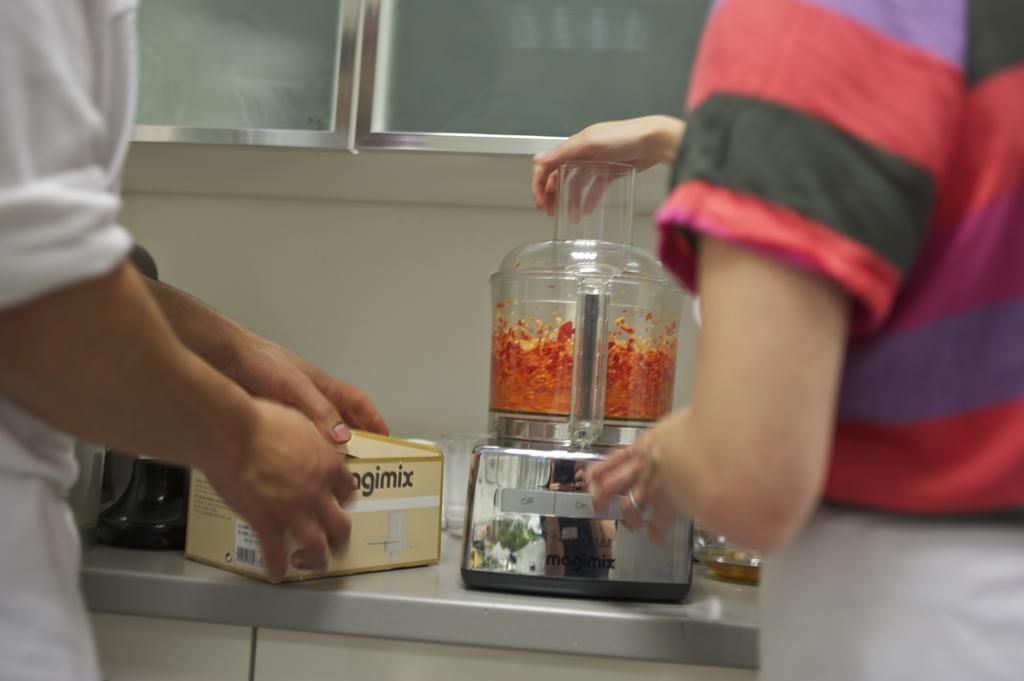Is the off button on the mixer on the left?
Offer a terse response. Yes. 